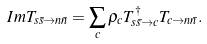<formula> <loc_0><loc_0><loc_500><loc_500>I m T _ { s \bar { s } \to n \bar { n } } = \sum _ { c } \rho _ { c } T ^ { \dagger } _ { s \bar { s } \to c } T _ { c \to n \bar { n } } .</formula> 